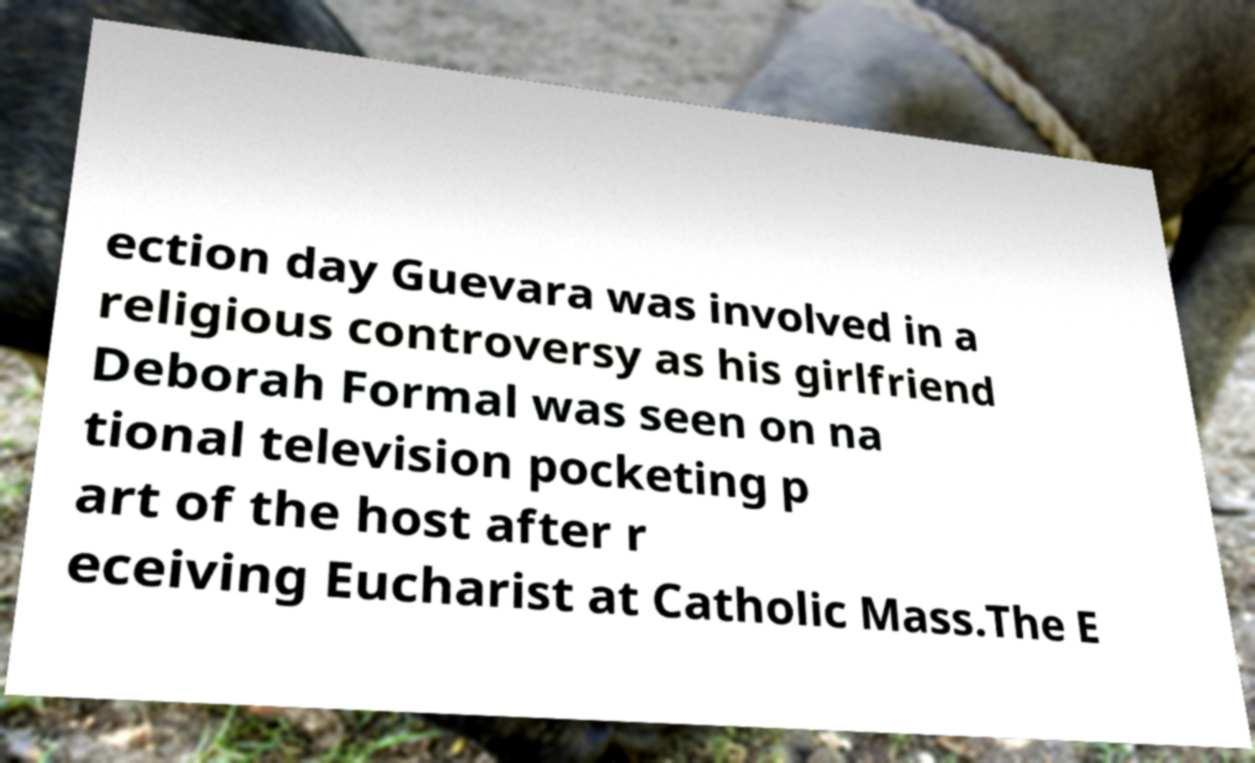Can you accurately transcribe the text from the provided image for me? ection day Guevara was involved in a religious controversy as his girlfriend Deborah Formal was seen on na tional television pocketing p art of the host after r eceiving Eucharist at Catholic Mass.The E 